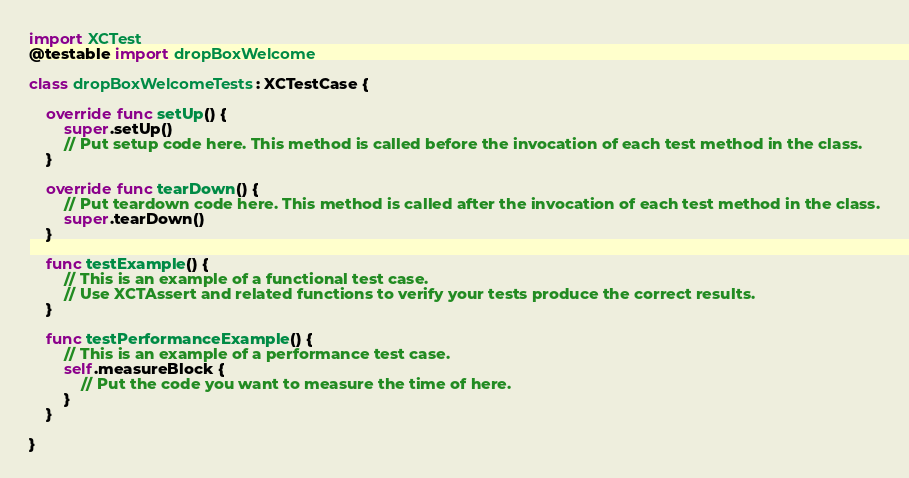Convert code to text. <code><loc_0><loc_0><loc_500><loc_500><_Swift_>
import XCTest
@testable import dropBoxWelcome

class dropBoxWelcomeTests: XCTestCase {
    
    override func setUp() {
        super.setUp()
        // Put setup code here. This method is called before the invocation of each test method in the class.
    }
    
    override func tearDown() {
        // Put teardown code here. This method is called after the invocation of each test method in the class.
        super.tearDown()
    }
    
    func testExample() {
        // This is an example of a functional test case.
        // Use XCTAssert and related functions to verify your tests produce the correct results.
    }
    
    func testPerformanceExample() {
        // This is an example of a performance test case.
        self.measureBlock {
            // Put the code you want to measure the time of here.
        }
    }
    
}
</code> 